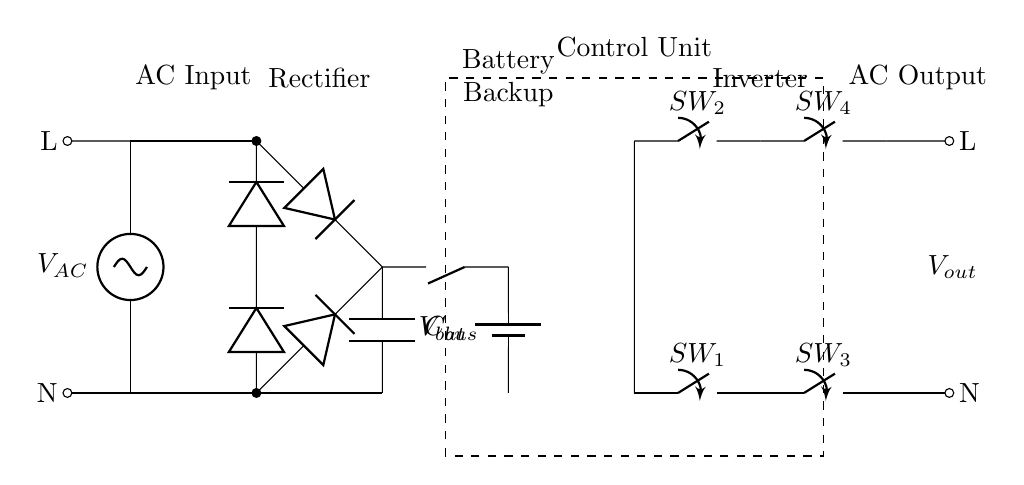What is the type of battery used in this UPS circuit? The circuit diagram indicates the use of a single battery represented by the symbol for a battery. The label on the component is $V_{bat}$.
Answer: Battery What does the capacitor labeled $C_{bus}$ do in this circuit? The capacitor $C_{bus}$ is part of the DC bus and is used to smooth out the output from the rectifier. It stores charge and helps maintain a stable voltage level during operation.
Answer: Smoothing How many switches are in the inverter section of the circuit? There are four switches in the inverter section, denoted as $SW_1$, $SW_2$, $SW_3$, and $SW_4$. They are responsible for controlling the flow of electricity in various paths during the conversion from DC to AC.
Answer: Four What is the purpose of the control unit in this UPS circuit? The control unit oversees the operation of the UPS, managing interactions between the AC input, battery, inverter, and output based on the system’s operating conditions, ensuring reliability.
Answer: Management What is the output voltage type labeled in this UPS circuit? The output voltage is labeled as $V_{out}$, and since it is connected to the output terminals, it indicates that this circuit produces AC voltage for connected loads.
Answer: AC voltage 